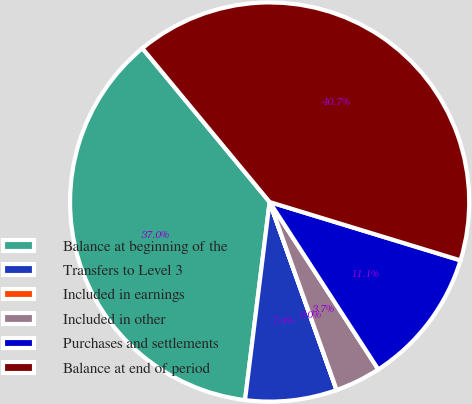<chart> <loc_0><loc_0><loc_500><loc_500><pie_chart><fcel>Balance at beginning of the<fcel>Transfers to Level 3<fcel>Included in earnings<fcel>Included in other<fcel>Purchases and settlements<fcel>Balance at end of period<nl><fcel>37.02%<fcel>7.41%<fcel>0.01%<fcel>3.71%<fcel>11.11%<fcel>40.72%<nl></chart> 